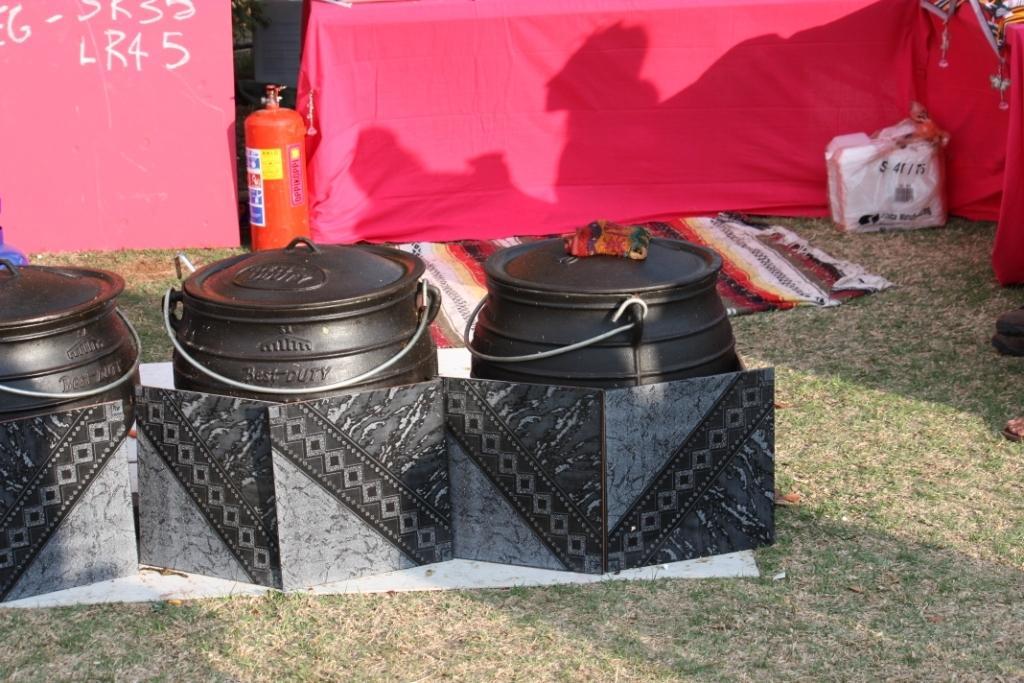Can you describe this image briefly? In this image I can see few black color cans,emergency cylinder,floor mat and some objects on the ground. Back I can see red color cloth. 